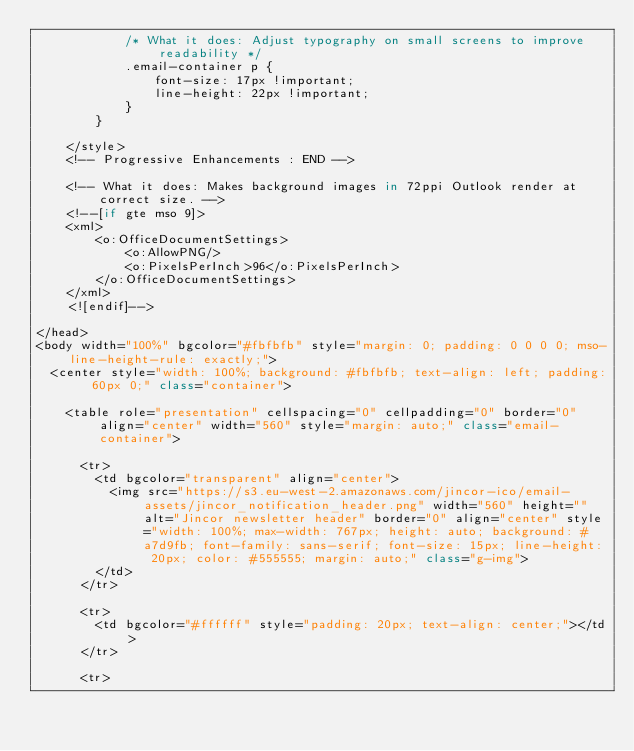Convert code to text. <code><loc_0><loc_0><loc_500><loc_500><_TypeScript_>            /* What it does: Adjust typography on small screens to improve readability */
            .email-container p {
                font-size: 17px !important;
                line-height: 22px !important;
            }
        }

    </style>
    <!-- Progressive Enhancements : END -->

    <!-- What it does: Makes background images in 72ppi Outlook render at correct size. -->
    <!--[if gte mso 9]>
    <xml>
        <o:OfficeDocumentSettings>
            <o:AllowPNG/>
            <o:PixelsPerInch>96</o:PixelsPerInch>
        </o:OfficeDocumentSettings>
    </xml>
    <![endif]-->

</head>
<body width="100%" bgcolor="#fbfbfb" style="margin: 0; padding: 0 0 0 0; mso-line-height-rule: exactly;">
  <center style="width: 100%; background: #fbfbfb; text-align: left; padding: 60px 0;" class="container">

    <table role="presentation" cellspacing="0" cellpadding="0" border="0" align="center" width="560" style="margin: auto;" class="email-container">

      <tr>
        <td bgcolor="transparent" align="center">
          <img src="https://s3.eu-west-2.amazonaws.com/jincor-ico/email-assets/jincor_notification_header.png" width="560" height="" alt="Jincor newsletter header" border="0" align="center" style="width: 100%; max-width: 767px; height: auto; background: #a7d9fb; font-family: sans-serif; font-size: 15px; line-height: 20px; color: #555555; margin: auto;" class="g-img">
        </td>
      </tr>

      <tr>
        <td bgcolor="#ffffff" style="padding: 20px; text-align: center;"></td>
      </tr>

      <tr></code> 